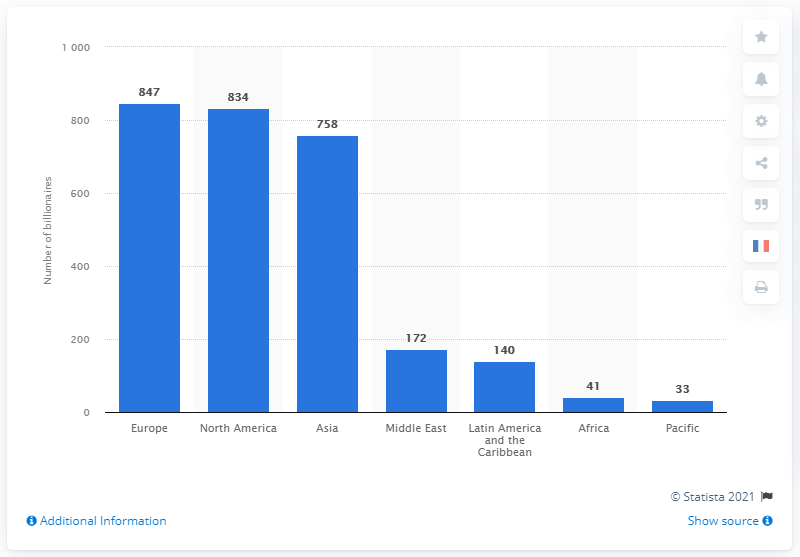Specify some key components in this picture. In 2019, there were 847 billionaires residing in Europe. 